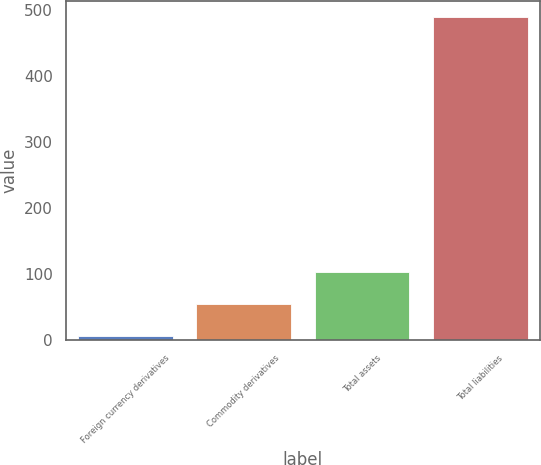Convert chart to OTSL. <chart><loc_0><loc_0><loc_500><loc_500><bar_chart><fcel>Foreign currency derivatives<fcel>Commodity derivatives<fcel>Total assets<fcel>Total liabilities<nl><fcel>6<fcel>54.4<fcel>102.8<fcel>490<nl></chart> 